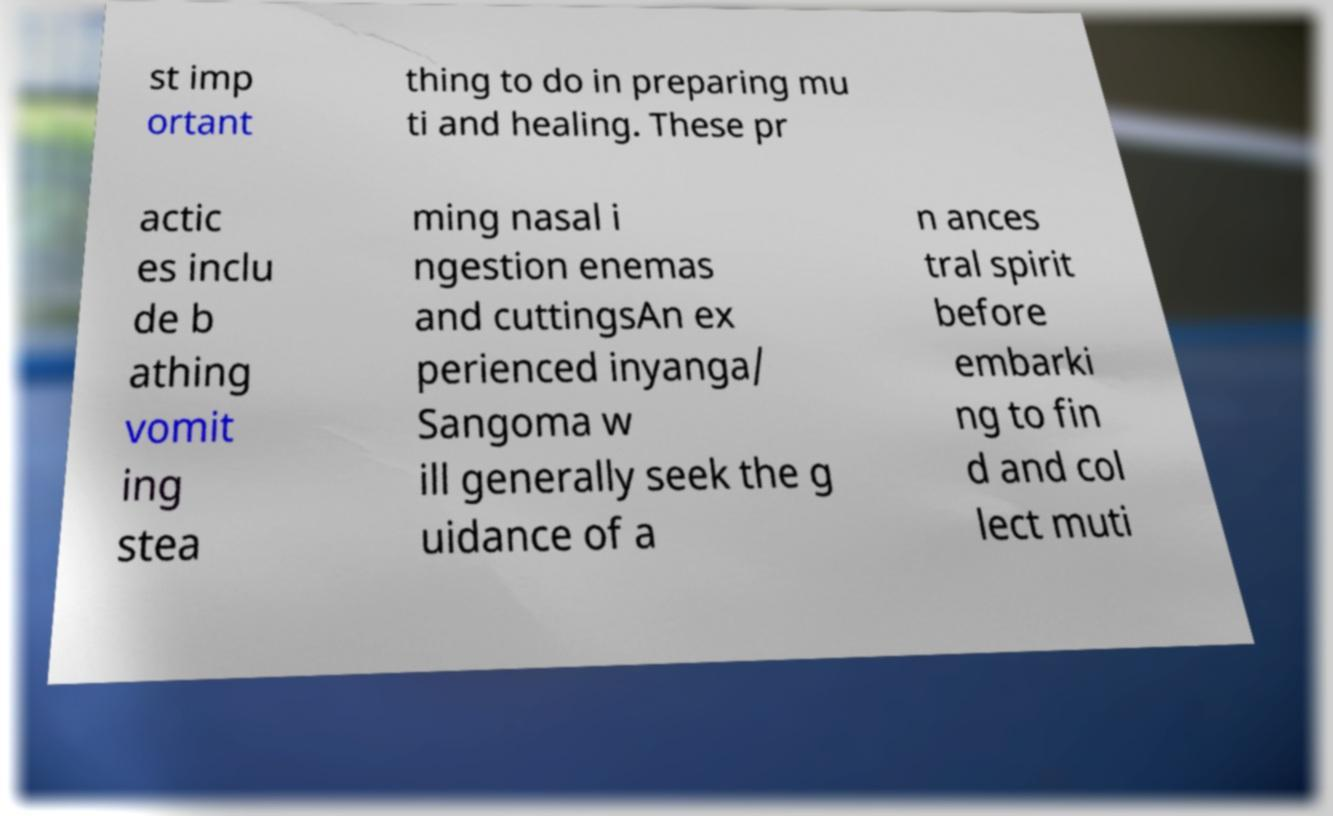Could you extract and type out the text from this image? st imp ortant thing to do in preparing mu ti and healing. These pr actic es inclu de b athing vomit ing stea ming nasal i ngestion enemas and cuttingsAn ex perienced inyanga/ Sangoma w ill generally seek the g uidance of a n ances tral spirit before embarki ng to fin d and col lect muti 